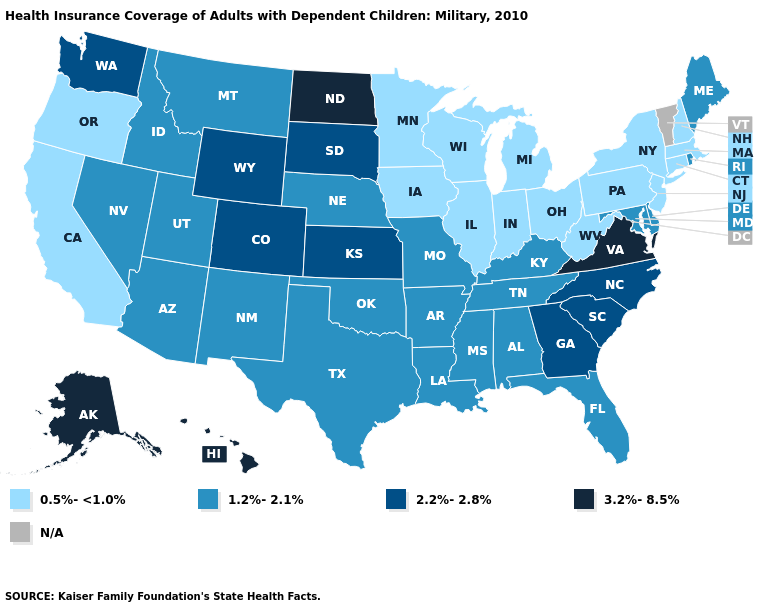Name the states that have a value in the range 2.2%-2.8%?
Answer briefly. Colorado, Georgia, Kansas, North Carolina, South Carolina, South Dakota, Washington, Wyoming. Does North Dakota have the lowest value in the MidWest?
Short answer required. No. Name the states that have a value in the range 2.2%-2.8%?
Quick response, please. Colorado, Georgia, Kansas, North Carolina, South Carolina, South Dakota, Washington, Wyoming. What is the value of Indiana?
Concise answer only. 0.5%-<1.0%. What is the value of Nevada?
Give a very brief answer. 1.2%-2.1%. Name the states that have a value in the range 2.2%-2.8%?
Keep it brief. Colorado, Georgia, Kansas, North Carolina, South Carolina, South Dakota, Washington, Wyoming. Name the states that have a value in the range 1.2%-2.1%?
Concise answer only. Alabama, Arizona, Arkansas, Delaware, Florida, Idaho, Kentucky, Louisiana, Maine, Maryland, Mississippi, Missouri, Montana, Nebraska, Nevada, New Mexico, Oklahoma, Rhode Island, Tennessee, Texas, Utah. What is the value of South Carolina?
Concise answer only. 2.2%-2.8%. How many symbols are there in the legend?
Concise answer only. 5. What is the value of Missouri?
Answer briefly. 1.2%-2.1%. Name the states that have a value in the range 1.2%-2.1%?
Quick response, please. Alabama, Arizona, Arkansas, Delaware, Florida, Idaho, Kentucky, Louisiana, Maine, Maryland, Mississippi, Missouri, Montana, Nebraska, Nevada, New Mexico, Oklahoma, Rhode Island, Tennessee, Texas, Utah. Does Indiana have the lowest value in the USA?
Give a very brief answer. Yes. What is the lowest value in the USA?
Quick response, please. 0.5%-<1.0%. Does the map have missing data?
Concise answer only. Yes. 